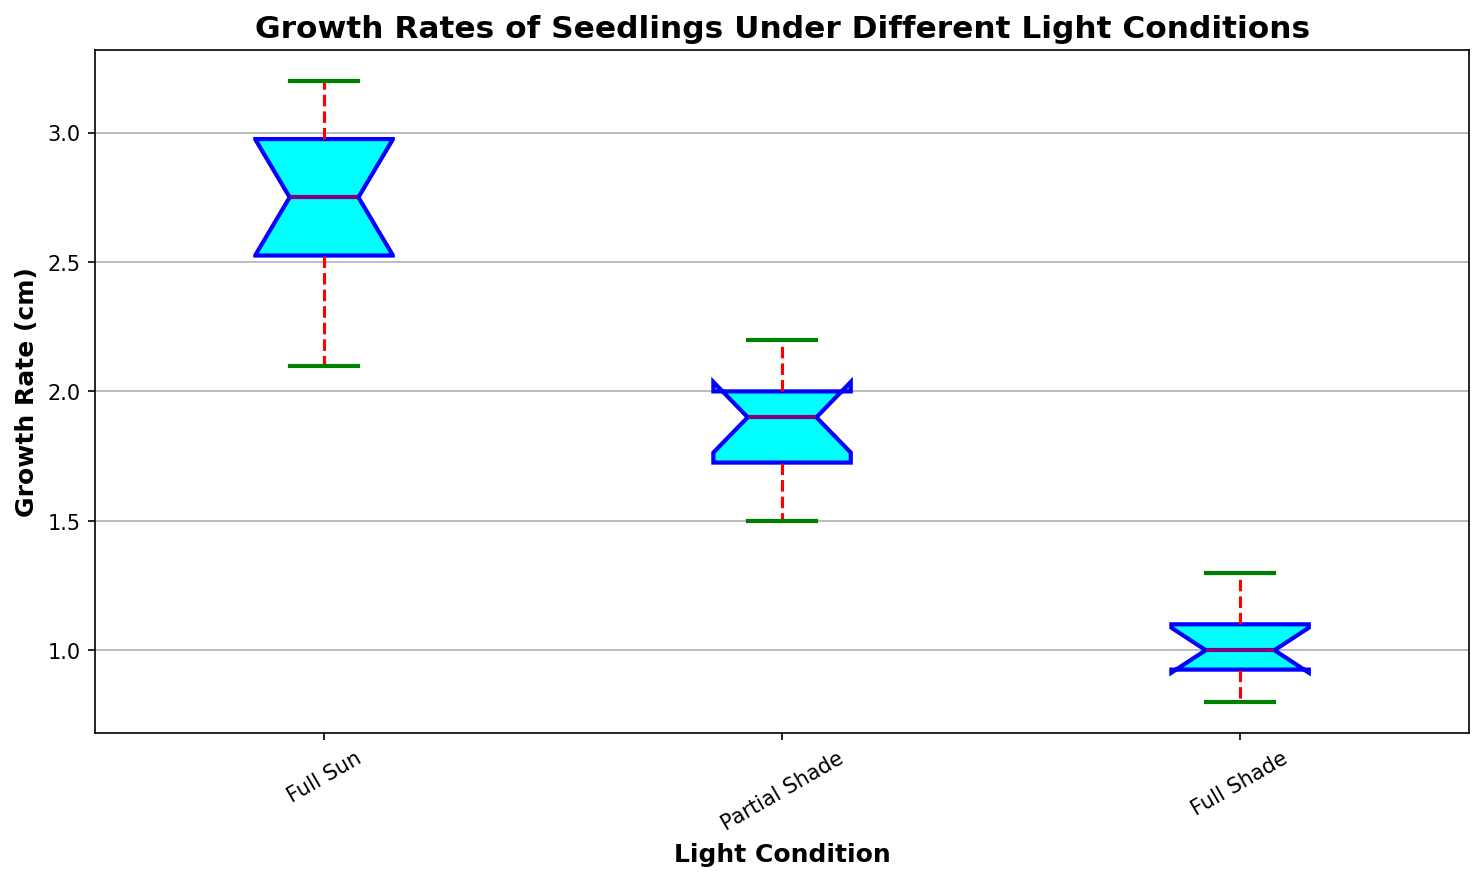What is the median growth rate for seedlings in Full Sun condition? Locate the middle line within the box for Full Sun condition on the box plot, which represents the median.
Answer: 2.8 cm Which light condition has the highest median growth rate? Compare the median lines within the boxes for all light conditions (Full Sun, Partial Shade, and Full Shade). The highest median line is at Full Sun.
Answer: Full Sun Which light condition shows the most variation in growth rates? Compare the lengths of the boxes and the whiskers for each light condition. The longest box and whiskers indicate the most variation.
Answer: Full Sun How does the median growth rate of Partial Shade compare to Full Shade? Examine the median lines of Partial Shade and Full Shade boxes. The Partial Shade median is visibly higher than the Full Shade median.
Answer: Higher What is the range of growth rates for Full Shade condition? Identify the top and bottom whisker for Full Shade condition. Subtract the minimum value from the maximum value (1.3 cm - 0.8 cm).
Answer: 0.5 cm Which light condition has the smallest interquartile range (IQR)? Compare the heights of the boxes (the IQR) across all light conditions. The smallest height represents the smallest IQR.
Answer: Full Shade What is the upper quartile (Q3) growth rate for Partial Shade? Identify the top boundary of the box for Partial Shade, which represents Q3.
Answer: 2.0 cm Which condition has the higher upper whisker value, Partial Shade or Full Shade? Compare the end points of the upper whiskers for Partial Shade and Full Shade. The higher value is from Partial Shade.
Answer: Partial Shade Are there any outliers in the Full Sun condition? Look for any points outside the whiskers for the Full Sun condition. There are no such points.
Answer: No By how much does the median growth rate of Full Sun exceed that of Partial Shade? Subtract the median of Partial Shade (1.9 cm) from the median of Full Sun (2.8 cm).
Answer: 0.9 cm 